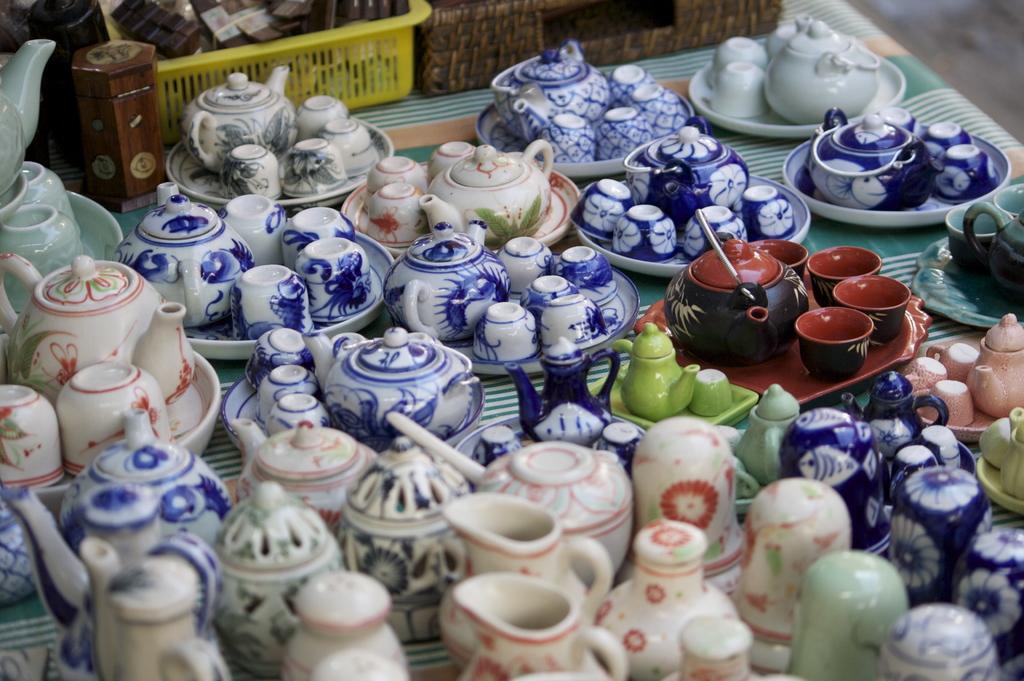Describe this image in one or two sentences. In the image there are many ceramic kettles,cups and saucers on a table, in the back there is a tray with some vessels on it. 